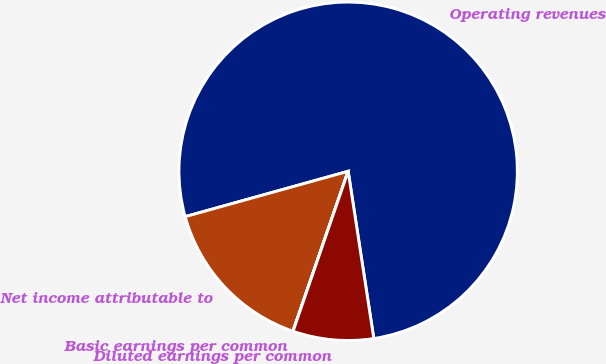Convert chart. <chart><loc_0><loc_0><loc_500><loc_500><pie_chart><fcel>Operating revenues<fcel>Net income attributable to<fcel>Basic earnings per common<fcel>Diluted earnings per common<nl><fcel>76.9%<fcel>15.39%<fcel>0.01%<fcel>7.7%<nl></chart> 